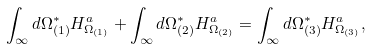Convert formula to latex. <formula><loc_0><loc_0><loc_500><loc_500>\int _ { \infty } d \Omega _ { ( 1 ) } ^ { * } H _ { \Omega _ { ( 1 ) } } ^ { a } + \int _ { \infty } d \Omega _ { ( 2 ) } ^ { * } H _ { \Omega _ { ( 2 ) } } ^ { a } = \int _ { \infty } d \Omega _ { ( 3 ) } ^ { * } H _ { \Omega _ { ( 3 ) } } ^ { a } ,</formula> 